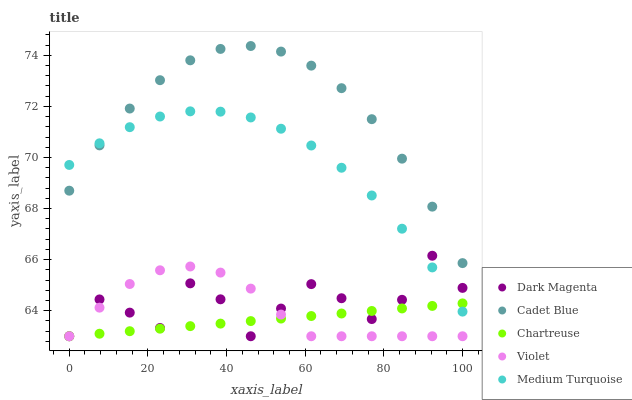Does Chartreuse have the minimum area under the curve?
Answer yes or no. Yes. Does Cadet Blue have the maximum area under the curve?
Answer yes or no. Yes. Does Dark Magenta have the minimum area under the curve?
Answer yes or no. No. Does Dark Magenta have the maximum area under the curve?
Answer yes or no. No. Is Chartreuse the smoothest?
Answer yes or no. Yes. Is Dark Magenta the roughest?
Answer yes or no. Yes. Is Cadet Blue the smoothest?
Answer yes or no. No. Is Cadet Blue the roughest?
Answer yes or no. No. Does Chartreuse have the lowest value?
Answer yes or no. Yes. Does Cadet Blue have the lowest value?
Answer yes or no. No. Does Cadet Blue have the highest value?
Answer yes or no. Yes. Does Dark Magenta have the highest value?
Answer yes or no. No. Is Violet less than Cadet Blue?
Answer yes or no. Yes. Is Cadet Blue greater than Chartreuse?
Answer yes or no. Yes. Does Cadet Blue intersect Medium Turquoise?
Answer yes or no. Yes. Is Cadet Blue less than Medium Turquoise?
Answer yes or no. No. Is Cadet Blue greater than Medium Turquoise?
Answer yes or no. No. Does Violet intersect Cadet Blue?
Answer yes or no. No. 